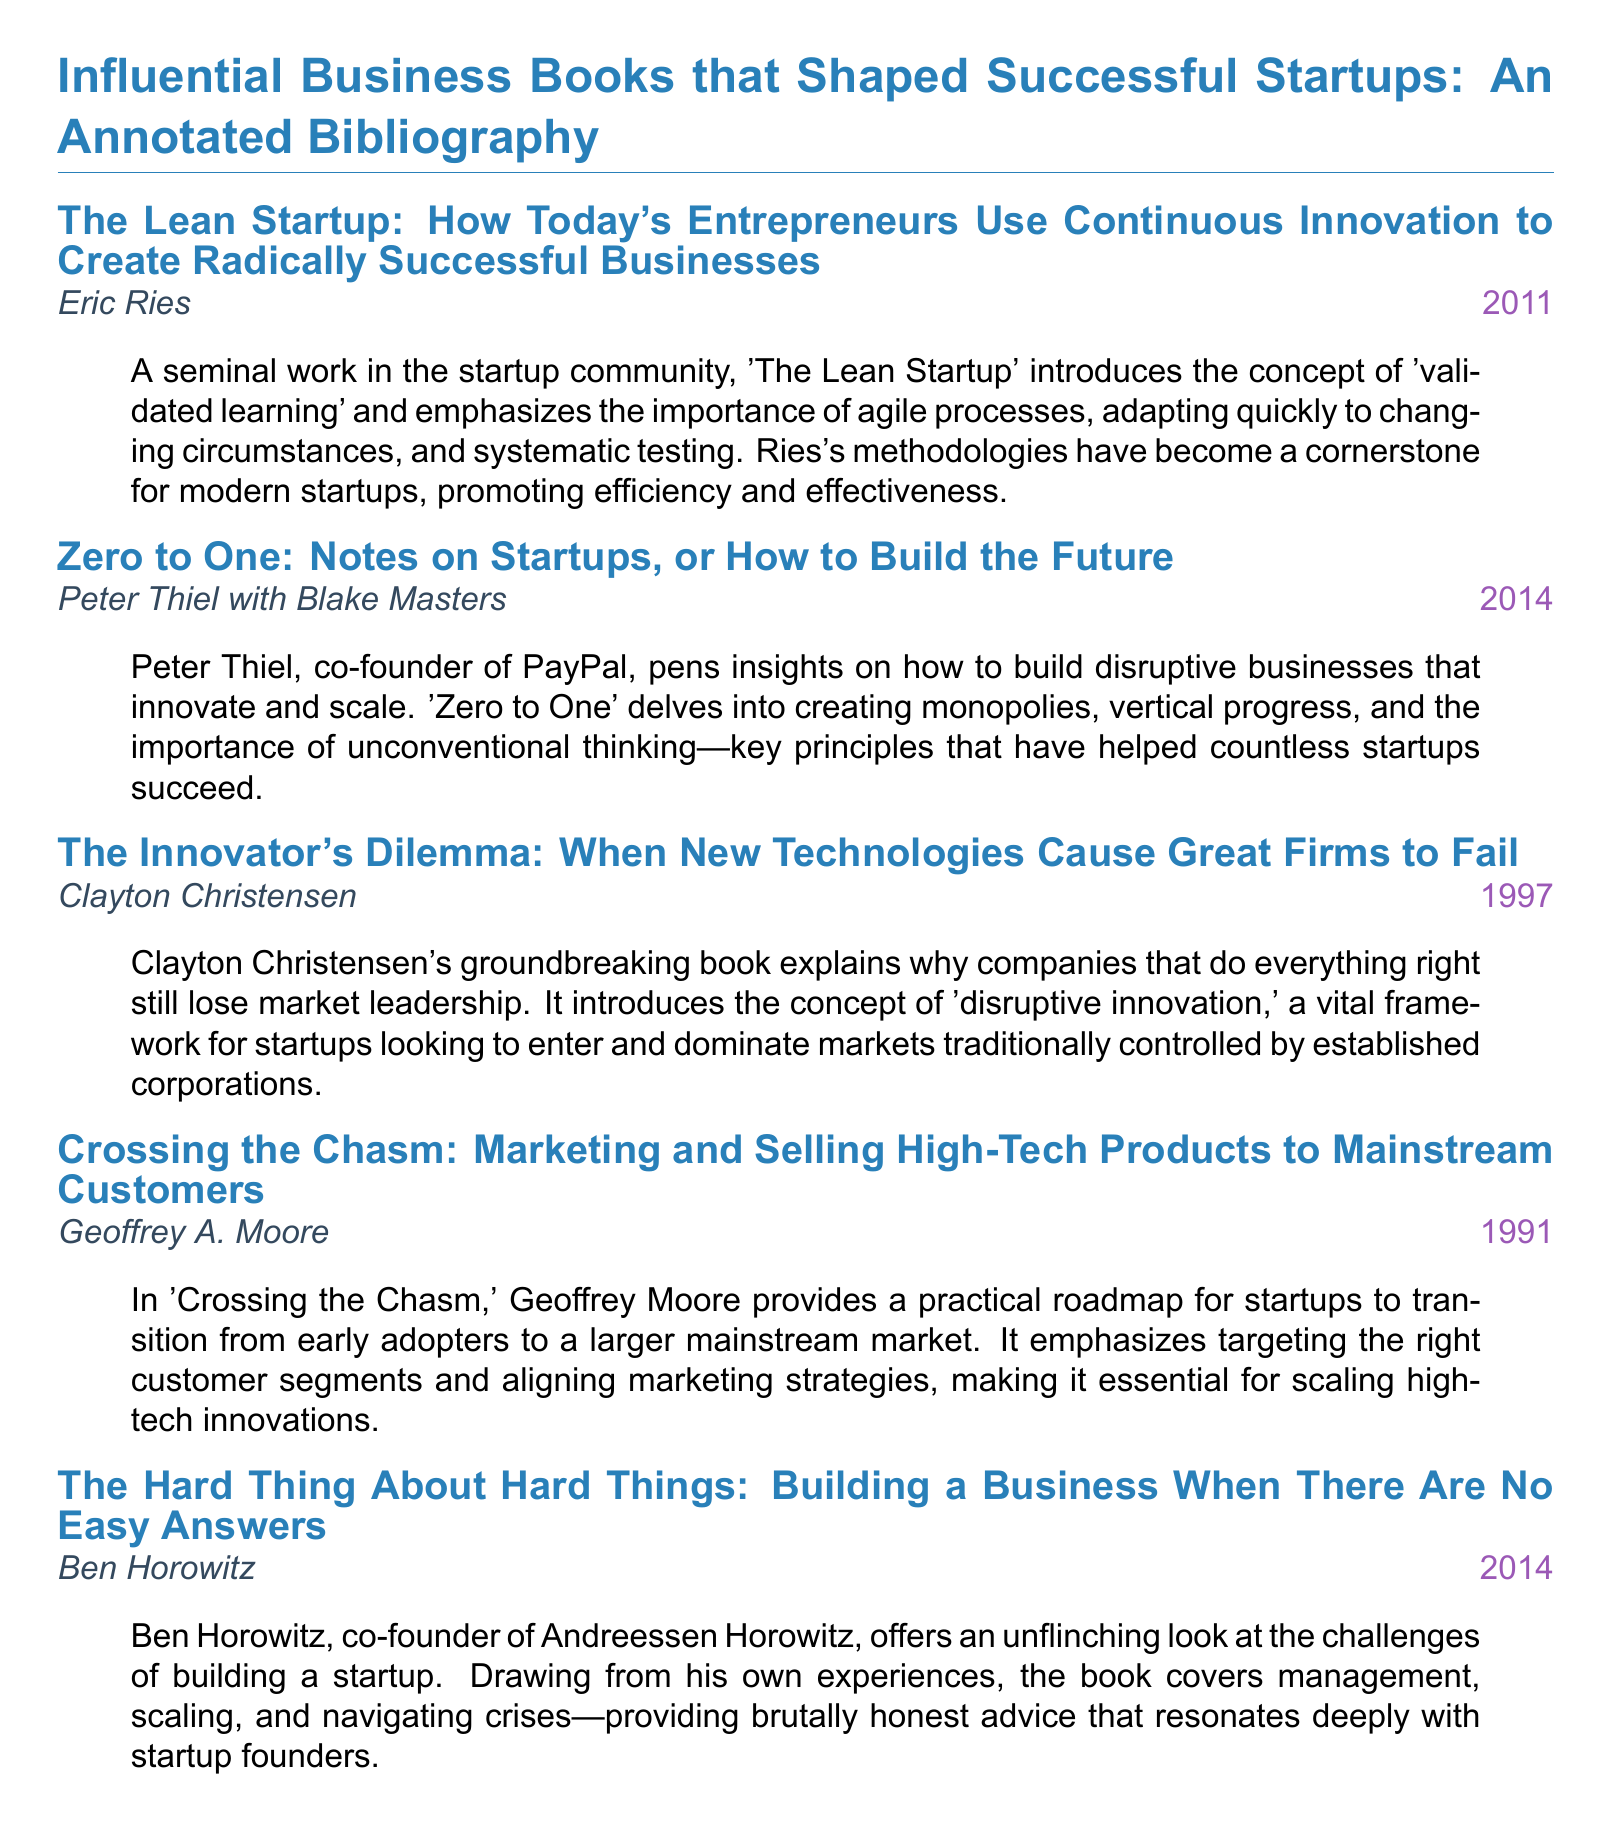What is the title of the first book? The title of the first book is given at the beginning of the first item, which is "The Lean Startup: How Today's Entrepreneurs Use Continuous Innovation to Create Radically Successful Businesses."
Answer: The Lean Startup: How Today's Entrepreneurs Use Continuous Innovation to Create Radically Successful Businesses Who is the author of "Zero to One"? The author of "Zero to One" is noted directly below the book title, indicating that it is Peter Thiel with Blake Masters.
Answer: Peter Thiel with Blake Masters What year was "The Innovator’s Dilemma" published? The publication year is clearly displayed next to the author's name, which is 1997.
Answer: 1997 What concept does "The Lean Startup" emphasize? The document explains that "The Lean Startup" introduces the concept of "validated learning," highlighting its significance in startup processes.
Answer: Validated learning Which book discusses the challenges of building a startup? The book that addresses startup challenges is mentioned after its title, indicating it is "The Hard Thing About Hard Things."
Answer: The Hard Thing About Hard Things How many books are listed in the bibliography? By counting the listed items in the document, we can determine the total. There are five separate book entries.
Answer: Five What does "Crossing the Chasm" provide for startups? The document states that "Crossing the Chasm" provides a practical roadmap for startups, indicating its focus on guidance.
Answer: A practical roadmap What unique concept is introduced in "The Innovator's Dilemma"? The document describes that the unique concept introduced is "disruptive innovation," which is crucial for startups.
Answer: Disruptive innovation 